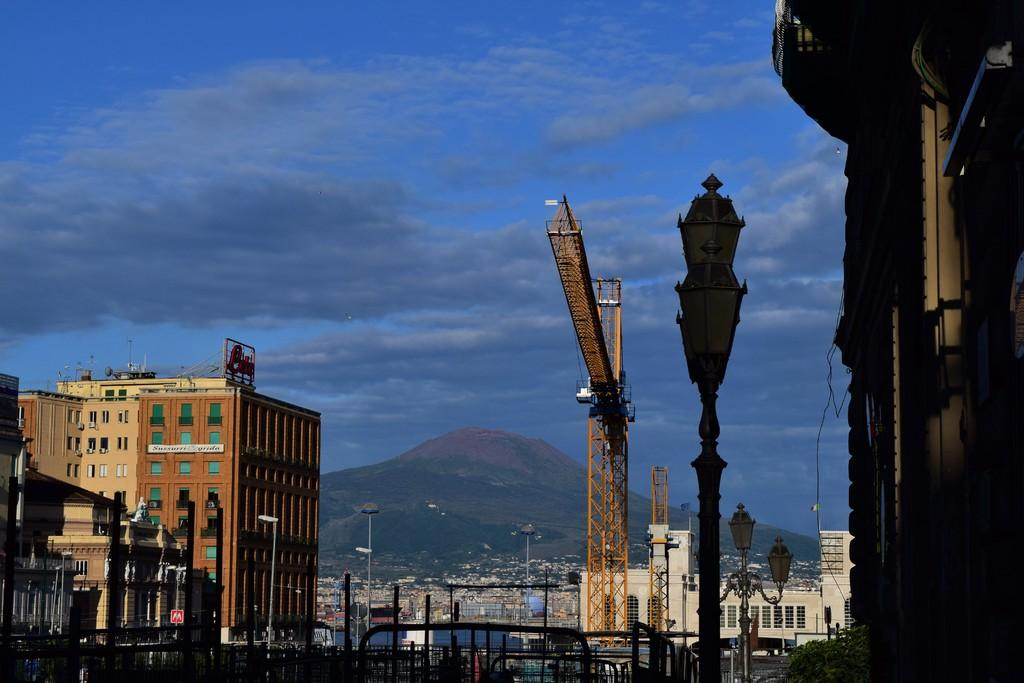What type of structures can be seen in the image? There are buildings in the image. What else can be seen in the image besides the buildings? There are light poles visible in the image. What is visible in the background of the image? Mountains can be seen in the background of the image. What is the condition of the sky in the image? The sky appears to be cloudy in the image. How many sheep are grazing in the pocket of the image? There are no sheep present in the image, and the concept of a "pocket" in an image is not applicable. What type of snack is being served in the popcorn machine in the image? There is no popcorn machine present in the image. 